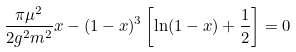<formula> <loc_0><loc_0><loc_500><loc_500>\frac { \pi \mu ^ { 2 } } { 2 g ^ { 2 } m ^ { 2 } } x - ( 1 - x ) ^ { 3 } \left [ \ln ( 1 - x ) + \frac { 1 } { 2 } \right ] = 0 \,</formula> 